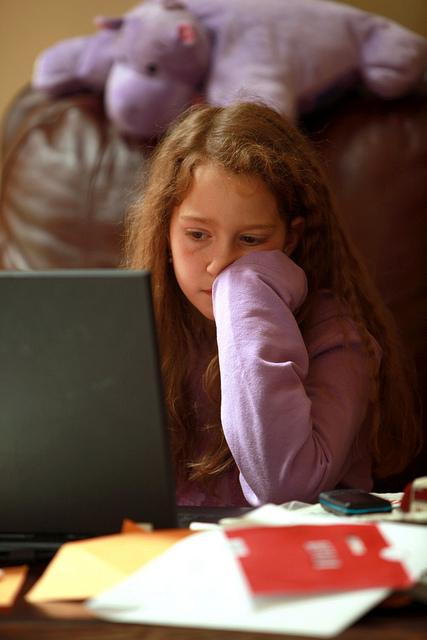Is there a keyboard in the picture?
Be succinct. No. What color is the phone case?
Give a very brief answer. Blue. What is the girl trying to do?
Give a very brief answer. Study. What kind of room, is this?
Give a very brief answer. Living room. What is this girl doing?
Short answer required. Reading. Who is the author of the book?
Keep it brief. No book. What laying on the book?
Be succinct. Netflix envelope. What is in the immediate foreground?
Quick response, please. Laptop. Is the girl hungry?
Keep it brief. No. Does this person have glasses?
Answer briefly. No. Does she look happy?
Quick response, please. No. What color is the woman's sweater?
Be succinct. Purple. What is on the chair behind the girl?
Be succinct. Stuffed animal. What nationality is the person in the picture?
Keep it brief. American. 